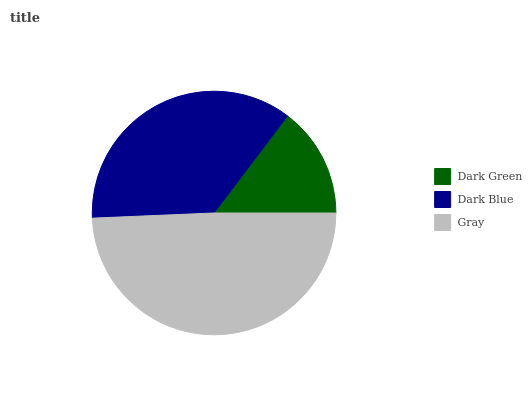Is Dark Green the minimum?
Answer yes or no. Yes. Is Gray the maximum?
Answer yes or no. Yes. Is Dark Blue the minimum?
Answer yes or no. No. Is Dark Blue the maximum?
Answer yes or no. No. Is Dark Blue greater than Dark Green?
Answer yes or no. Yes. Is Dark Green less than Dark Blue?
Answer yes or no. Yes. Is Dark Green greater than Dark Blue?
Answer yes or no. No. Is Dark Blue less than Dark Green?
Answer yes or no. No. Is Dark Blue the high median?
Answer yes or no. Yes. Is Dark Blue the low median?
Answer yes or no. Yes. Is Dark Green the high median?
Answer yes or no. No. Is Gray the low median?
Answer yes or no. No. 